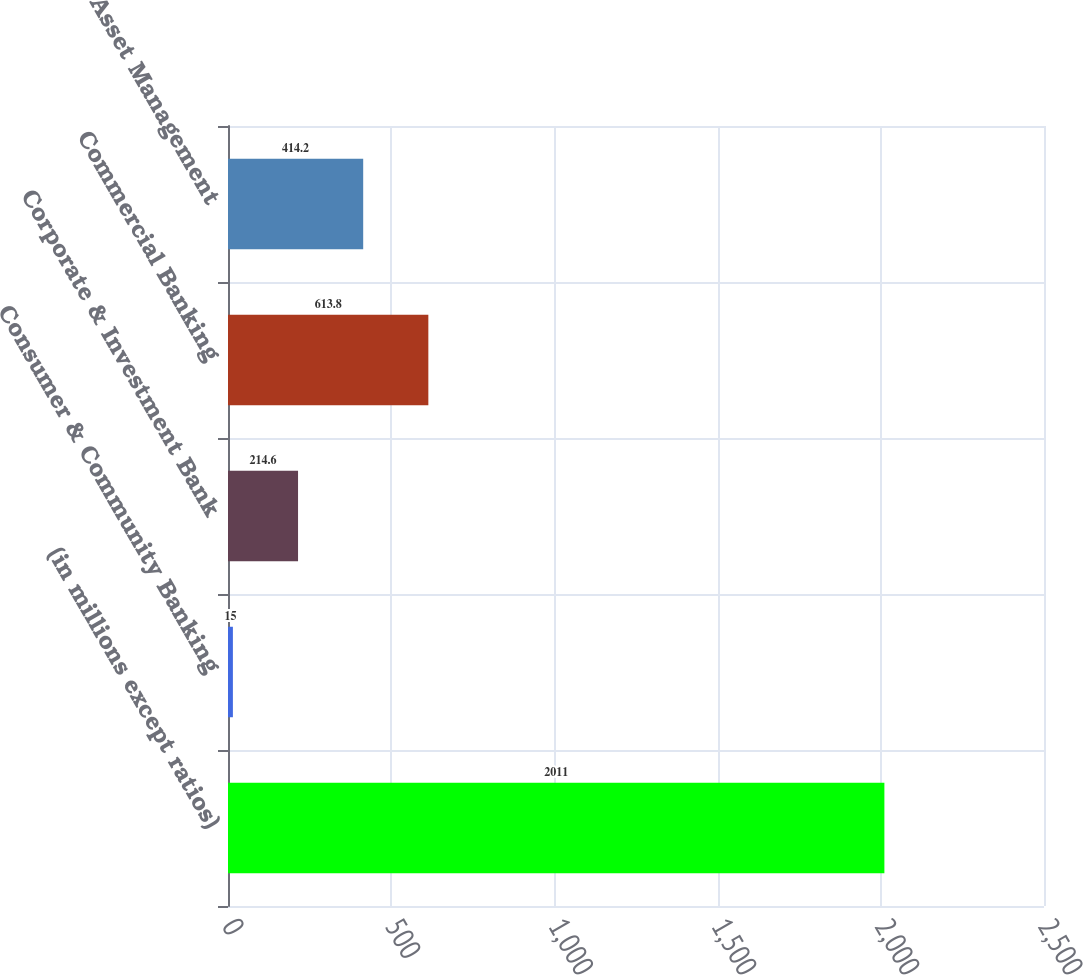<chart> <loc_0><loc_0><loc_500><loc_500><bar_chart><fcel>(in millions except ratios)<fcel>Consumer & Community Banking<fcel>Corporate & Investment Bank<fcel>Commercial Banking<fcel>Asset Management<nl><fcel>2011<fcel>15<fcel>214.6<fcel>613.8<fcel>414.2<nl></chart> 